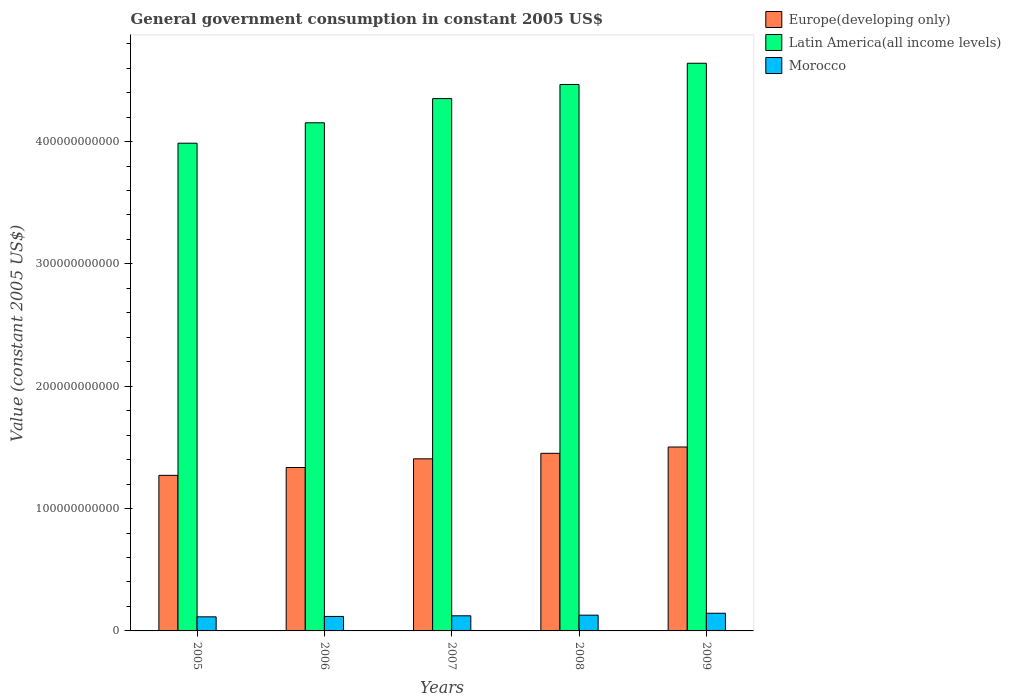Are the number of bars on each tick of the X-axis equal?
Offer a terse response. Yes. What is the label of the 2nd group of bars from the left?
Your answer should be very brief. 2006. In how many cases, is the number of bars for a given year not equal to the number of legend labels?
Keep it short and to the point. 0. What is the government conusmption in Morocco in 2007?
Your answer should be compact. 1.24e+1. Across all years, what is the maximum government conusmption in Europe(developing only)?
Offer a very short reply. 1.50e+11. Across all years, what is the minimum government conusmption in Morocco?
Your response must be concise. 1.15e+1. In which year was the government conusmption in Latin America(all income levels) maximum?
Give a very brief answer. 2009. What is the total government conusmption in Latin America(all income levels) in the graph?
Provide a succinct answer. 2.16e+12. What is the difference between the government conusmption in Latin America(all income levels) in 2006 and that in 2008?
Your answer should be very brief. -3.13e+1. What is the difference between the government conusmption in Latin America(all income levels) in 2005 and the government conusmption in Europe(developing only) in 2009?
Make the answer very short. 2.48e+11. What is the average government conusmption in Morocco per year?
Keep it short and to the point. 1.26e+1. In the year 2005, what is the difference between the government conusmption in Europe(developing only) and government conusmption in Morocco?
Offer a very short reply. 1.16e+11. In how many years, is the government conusmption in Morocco greater than 40000000000 US$?
Keep it short and to the point. 0. What is the ratio of the government conusmption in Morocco in 2006 to that in 2008?
Provide a short and direct response. 0.92. Is the difference between the government conusmption in Europe(developing only) in 2007 and 2009 greater than the difference between the government conusmption in Morocco in 2007 and 2009?
Provide a succinct answer. No. What is the difference between the highest and the second highest government conusmption in Europe(developing only)?
Keep it short and to the point. 5.17e+09. What is the difference between the highest and the lowest government conusmption in Morocco?
Offer a very short reply. 2.93e+09. Is the sum of the government conusmption in Europe(developing only) in 2007 and 2008 greater than the maximum government conusmption in Morocco across all years?
Provide a short and direct response. Yes. What does the 3rd bar from the left in 2009 represents?
Make the answer very short. Morocco. What does the 2nd bar from the right in 2006 represents?
Make the answer very short. Latin America(all income levels). Is it the case that in every year, the sum of the government conusmption in Morocco and government conusmption in Latin America(all income levels) is greater than the government conusmption in Europe(developing only)?
Make the answer very short. Yes. How many years are there in the graph?
Your answer should be compact. 5. What is the difference between two consecutive major ticks on the Y-axis?
Give a very brief answer. 1.00e+11. Are the values on the major ticks of Y-axis written in scientific E-notation?
Keep it short and to the point. No. Does the graph contain any zero values?
Keep it short and to the point. No. Does the graph contain grids?
Make the answer very short. No. Where does the legend appear in the graph?
Offer a very short reply. Top right. What is the title of the graph?
Your response must be concise. General government consumption in constant 2005 US$. Does "Uzbekistan" appear as one of the legend labels in the graph?
Ensure brevity in your answer.  No. What is the label or title of the Y-axis?
Provide a succinct answer. Value (constant 2005 US$). What is the Value (constant 2005 US$) of Europe(developing only) in 2005?
Provide a short and direct response. 1.27e+11. What is the Value (constant 2005 US$) in Latin America(all income levels) in 2005?
Your answer should be compact. 3.99e+11. What is the Value (constant 2005 US$) of Morocco in 2005?
Offer a terse response. 1.15e+1. What is the Value (constant 2005 US$) in Europe(developing only) in 2006?
Offer a very short reply. 1.34e+11. What is the Value (constant 2005 US$) in Latin America(all income levels) in 2006?
Offer a terse response. 4.15e+11. What is the Value (constant 2005 US$) of Morocco in 2006?
Make the answer very short. 1.18e+1. What is the Value (constant 2005 US$) in Europe(developing only) in 2007?
Provide a succinct answer. 1.41e+11. What is the Value (constant 2005 US$) in Latin America(all income levels) in 2007?
Offer a very short reply. 4.35e+11. What is the Value (constant 2005 US$) in Morocco in 2007?
Your answer should be very brief. 1.24e+1. What is the Value (constant 2005 US$) of Europe(developing only) in 2008?
Offer a very short reply. 1.45e+11. What is the Value (constant 2005 US$) of Latin America(all income levels) in 2008?
Your response must be concise. 4.47e+11. What is the Value (constant 2005 US$) of Morocco in 2008?
Your answer should be very brief. 1.29e+1. What is the Value (constant 2005 US$) of Europe(developing only) in 2009?
Give a very brief answer. 1.50e+11. What is the Value (constant 2005 US$) of Latin America(all income levels) in 2009?
Provide a succinct answer. 4.64e+11. What is the Value (constant 2005 US$) of Morocco in 2009?
Make the answer very short. 1.45e+1. Across all years, what is the maximum Value (constant 2005 US$) in Europe(developing only)?
Your answer should be compact. 1.50e+11. Across all years, what is the maximum Value (constant 2005 US$) of Latin America(all income levels)?
Ensure brevity in your answer.  4.64e+11. Across all years, what is the maximum Value (constant 2005 US$) in Morocco?
Make the answer very short. 1.45e+1. Across all years, what is the minimum Value (constant 2005 US$) in Europe(developing only)?
Ensure brevity in your answer.  1.27e+11. Across all years, what is the minimum Value (constant 2005 US$) in Latin America(all income levels)?
Provide a succinct answer. 3.99e+11. Across all years, what is the minimum Value (constant 2005 US$) of Morocco?
Provide a short and direct response. 1.15e+1. What is the total Value (constant 2005 US$) of Europe(developing only) in the graph?
Your answer should be very brief. 6.97e+11. What is the total Value (constant 2005 US$) of Latin America(all income levels) in the graph?
Your answer should be very brief. 2.16e+12. What is the total Value (constant 2005 US$) in Morocco in the graph?
Your answer should be very brief. 6.31e+1. What is the difference between the Value (constant 2005 US$) in Europe(developing only) in 2005 and that in 2006?
Keep it short and to the point. -6.40e+09. What is the difference between the Value (constant 2005 US$) in Latin America(all income levels) in 2005 and that in 2006?
Give a very brief answer. -1.67e+1. What is the difference between the Value (constant 2005 US$) of Morocco in 2005 and that in 2006?
Ensure brevity in your answer.  -3.30e+08. What is the difference between the Value (constant 2005 US$) in Europe(developing only) in 2005 and that in 2007?
Provide a short and direct response. -1.35e+1. What is the difference between the Value (constant 2005 US$) in Latin America(all income levels) in 2005 and that in 2007?
Give a very brief answer. -3.65e+1. What is the difference between the Value (constant 2005 US$) of Morocco in 2005 and that in 2007?
Offer a very short reply. -8.40e+08. What is the difference between the Value (constant 2005 US$) in Europe(developing only) in 2005 and that in 2008?
Your answer should be compact. -1.80e+1. What is the difference between the Value (constant 2005 US$) in Latin America(all income levels) in 2005 and that in 2008?
Ensure brevity in your answer.  -4.80e+1. What is the difference between the Value (constant 2005 US$) of Morocco in 2005 and that in 2008?
Offer a very short reply. -1.36e+09. What is the difference between the Value (constant 2005 US$) in Europe(developing only) in 2005 and that in 2009?
Provide a short and direct response. -2.32e+1. What is the difference between the Value (constant 2005 US$) of Latin America(all income levels) in 2005 and that in 2009?
Provide a short and direct response. -6.53e+1. What is the difference between the Value (constant 2005 US$) in Morocco in 2005 and that in 2009?
Make the answer very short. -2.93e+09. What is the difference between the Value (constant 2005 US$) of Europe(developing only) in 2006 and that in 2007?
Offer a terse response. -7.10e+09. What is the difference between the Value (constant 2005 US$) in Latin America(all income levels) in 2006 and that in 2007?
Make the answer very short. -1.98e+1. What is the difference between the Value (constant 2005 US$) of Morocco in 2006 and that in 2007?
Offer a terse response. -5.10e+08. What is the difference between the Value (constant 2005 US$) of Europe(developing only) in 2006 and that in 2008?
Make the answer very short. -1.16e+1. What is the difference between the Value (constant 2005 US$) in Latin America(all income levels) in 2006 and that in 2008?
Make the answer very short. -3.13e+1. What is the difference between the Value (constant 2005 US$) of Morocco in 2006 and that in 2008?
Make the answer very short. -1.03e+09. What is the difference between the Value (constant 2005 US$) of Europe(developing only) in 2006 and that in 2009?
Make the answer very short. -1.68e+1. What is the difference between the Value (constant 2005 US$) of Latin America(all income levels) in 2006 and that in 2009?
Your answer should be compact. -4.86e+1. What is the difference between the Value (constant 2005 US$) of Morocco in 2006 and that in 2009?
Offer a terse response. -2.60e+09. What is the difference between the Value (constant 2005 US$) of Europe(developing only) in 2007 and that in 2008?
Your response must be concise. -4.50e+09. What is the difference between the Value (constant 2005 US$) in Latin America(all income levels) in 2007 and that in 2008?
Your answer should be very brief. -1.15e+1. What is the difference between the Value (constant 2005 US$) of Morocco in 2007 and that in 2008?
Your response must be concise. -5.23e+08. What is the difference between the Value (constant 2005 US$) in Europe(developing only) in 2007 and that in 2009?
Your response must be concise. -9.67e+09. What is the difference between the Value (constant 2005 US$) in Latin America(all income levels) in 2007 and that in 2009?
Give a very brief answer. -2.89e+1. What is the difference between the Value (constant 2005 US$) in Morocco in 2007 and that in 2009?
Keep it short and to the point. -2.09e+09. What is the difference between the Value (constant 2005 US$) in Europe(developing only) in 2008 and that in 2009?
Provide a short and direct response. -5.17e+09. What is the difference between the Value (constant 2005 US$) in Latin America(all income levels) in 2008 and that in 2009?
Keep it short and to the point. -1.74e+1. What is the difference between the Value (constant 2005 US$) of Morocco in 2008 and that in 2009?
Your answer should be compact. -1.57e+09. What is the difference between the Value (constant 2005 US$) of Europe(developing only) in 2005 and the Value (constant 2005 US$) of Latin America(all income levels) in 2006?
Ensure brevity in your answer.  -2.88e+11. What is the difference between the Value (constant 2005 US$) in Europe(developing only) in 2005 and the Value (constant 2005 US$) in Morocco in 2006?
Provide a succinct answer. 1.15e+11. What is the difference between the Value (constant 2005 US$) of Latin America(all income levels) in 2005 and the Value (constant 2005 US$) of Morocco in 2006?
Your answer should be compact. 3.87e+11. What is the difference between the Value (constant 2005 US$) in Europe(developing only) in 2005 and the Value (constant 2005 US$) in Latin America(all income levels) in 2007?
Provide a succinct answer. -3.08e+11. What is the difference between the Value (constant 2005 US$) in Europe(developing only) in 2005 and the Value (constant 2005 US$) in Morocco in 2007?
Keep it short and to the point. 1.15e+11. What is the difference between the Value (constant 2005 US$) of Latin America(all income levels) in 2005 and the Value (constant 2005 US$) of Morocco in 2007?
Your answer should be compact. 3.86e+11. What is the difference between the Value (constant 2005 US$) of Europe(developing only) in 2005 and the Value (constant 2005 US$) of Latin America(all income levels) in 2008?
Keep it short and to the point. -3.19e+11. What is the difference between the Value (constant 2005 US$) of Europe(developing only) in 2005 and the Value (constant 2005 US$) of Morocco in 2008?
Your answer should be very brief. 1.14e+11. What is the difference between the Value (constant 2005 US$) in Latin America(all income levels) in 2005 and the Value (constant 2005 US$) in Morocco in 2008?
Your response must be concise. 3.86e+11. What is the difference between the Value (constant 2005 US$) in Europe(developing only) in 2005 and the Value (constant 2005 US$) in Latin America(all income levels) in 2009?
Provide a short and direct response. -3.37e+11. What is the difference between the Value (constant 2005 US$) in Europe(developing only) in 2005 and the Value (constant 2005 US$) in Morocco in 2009?
Offer a very short reply. 1.13e+11. What is the difference between the Value (constant 2005 US$) in Latin America(all income levels) in 2005 and the Value (constant 2005 US$) in Morocco in 2009?
Your response must be concise. 3.84e+11. What is the difference between the Value (constant 2005 US$) of Europe(developing only) in 2006 and the Value (constant 2005 US$) of Latin America(all income levels) in 2007?
Your response must be concise. -3.02e+11. What is the difference between the Value (constant 2005 US$) in Europe(developing only) in 2006 and the Value (constant 2005 US$) in Morocco in 2007?
Your response must be concise. 1.21e+11. What is the difference between the Value (constant 2005 US$) in Latin America(all income levels) in 2006 and the Value (constant 2005 US$) in Morocco in 2007?
Offer a very short reply. 4.03e+11. What is the difference between the Value (constant 2005 US$) in Europe(developing only) in 2006 and the Value (constant 2005 US$) in Latin America(all income levels) in 2008?
Give a very brief answer. -3.13e+11. What is the difference between the Value (constant 2005 US$) of Europe(developing only) in 2006 and the Value (constant 2005 US$) of Morocco in 2008?
Your answer should be compact. 1.21e+11. What is the difference between the Value (constant 2005 US$) in Latin America(all income levels) in 2006 and the Value (constant 2005 US$) in Morocco in 2008?
Your answer should be compact. 4.02e+11. What is the difference between the Value (constant 2005 US$) of Europe(developing only) in 2006 and the Value (constant 2005 US$) of Latin America(all income levels) in 2009?
Your answer should be very brief. -3.30e+11. What is the difference between the Value (constant 2005 US$) of Europe(developing only) in 2006 and the Value (constant 2005 US$) of Morocco in 2009?
Provide a succinct answer. 1.19e+11. What is the difference between the Value (constant 2005 US$) of Latin America(all income levels) in 2006 and the Value (constant 2005 US$) of Morocco in 2009?
Your answer should be very brief. 4.01e+11. What is the difference between the Value (constant 2005 US$) of Europe(developing only) in 2007 and the Value (constant 2005 US$) of Latin America(all income levels) in 2008?
Your answer should be compact. -3.06e+11. What is the difference between the Value (constant 2005 US$) in Europe(developing only) in 2007 and the Value (constant 2005 US$) in Morocco in 2008?
Make the answer very short. 1.28e+11. What is the difference between the Value (constant 2005 US$) in Latin America(all income levels) in 2007 and the Value (constant 2005 US$) in Morocco in 2008?
Offer a terse response. 4.22e+11. What is the difference between the Value (constant 2005 US$) of Europe(developing only) in 2007 and the Value (constant 2005 US$) of Latin America(all income levels) in 2009?
Provide a succinct answer. -3.23e+11. What is the difference between the Value (constant 2005 US$) in Europe(developing only) in 2007 and the Value (constant 2005 US$) in Morocco in 2009?
Make the answer very short. 1.26e+11. What is the difference between the Value (constant 2005 US$) of Latin America(all income levels) in 2007 and the Value (constant 2005 US$) of Morocco in 2009?
Keep it short and to the point. 4.21e+11. What is the difference between the Value (constant 2005 US$) in Europe(developing only) in 2008 and the Value (constant 2005 US$) in Latin America(all income levels) in 2009?
Ensure brevity in your answer.  -3.19e+11. What is the difference between the Value (constant 2005 US$) of Europe(developing only) in 2008 and the Value (constant 2005 US$) of Morocco in 2009?
Your answer should be compact. 1.31e+11. What is the difference between the Value (constant 2005 US$) of Latin America(all income levels) in 2008 and the Value (constant 2005 US$) of Morocco in 2009?
Make the answer very short. 4.32e+11. What is the average Value (constant 2005 US$) of Europe(developing only) per year?
Your response must be concise. 1.39e+11. What is the average Value (constant 2005 US$) in Latin America(all income levels) per year?
Provide a succinct answer. 4.32e+11. What is the average Value (constant 2005 US$) in Morocco per year?
Make the answer very short. 1.26e+1. In the year 2005, what is the difference between the Value (constant 2005 US$) of Europe(developing only) and Value (constant 2005 US$) of Latin America(all income levels)?
Your response must be concise. -2.71e+11. In the year 2005, what is the difference between the Value (constant 2005 US$) in Europe(developing only) and Value (constant 2005 US$) in Morocco?
Your answer should be compact. 1.16e+11. In the year 2005, what is the difference between the Value (constant 2005 US$) in Latin America(all income levels) and Value (constant 2005 US$) in Morocco?
Your answer should be compact. 3.87e+11. In the year 2006, what is the difference between the Value (constant 2005 US$) of Europe(developing only) and Value (constant 2005 US$) of Latin America(all income levels)?
Your response must be concise. -2.82e+11. In the year 2006, what is the difference between the Value (constant 2005 US$) in Europe(developing only) and Value (constant 2005 US$) in Morocco?
Ensure brevity in your answer.  1.22e+11. In the year 2006, what is the difference between the Value (constant 2005 US$) of Latin America(all income levels) and Value (constant 2005 US$) of Morocco?
Keep it short and to the point. 4.03e+11. In the year 2007, what is the difference between the Value (constant 2005 US$) of Europe(developing only) and Value (constant 2005 US$) of Latin America(all income levels)?
Give a very brief answer. -2.94e+11. In the year 2007, what is the difference between the Value (constant 2005 US$) in Europe(developing only) and Value (constant 2005 US$) in Morocco?
Your response must be concise. 1.28e+11. In the year 2007, what is the difference between the Value (constant 2005 US$) in Latin America(all income levels) and Value (constant 2005 US$) in Morocco?
Your response must be concise. 4.23e+11. In the year 2008, what is the difference between the Value (constant 2005 US$) of Europe(developing only) and Value (constant 2005 US$) of Latin America(all income levels)?
Keep it short and to the point. -3.01e+11. In the year 2008, what is the difference between the Value (constant 2005 US$) in Europe(developing only) and Value (constant 2005 US$) in Morocco?
Offer a terse response. 1.32e+11. In the year 2008, what is the difference between the Value (constant 2005 US$) in Latin America(all income levels) and Value (constant 2005 US$) in Morocco?
Provide a short and direct response. 4.34e+11. In the year 2009, what is the difference between the Value (constant 2005 US$) of Europe(developing only) and Value (constant 2005 US$) of Latin America(all income levels)?
Your answer should be very brief. -3.14e+11. In the year 2009, what is the difference between the Value (constant 2005 US$) in Europe(developing only) and Value (constant 2005 US$) in Morocco?
Your answer should be very brief. 1.36e+11. In the year 2009, what is the difference between the Value (constant 2005 US$) of Latin America(all income levels) and Value (constant 2005 US$) of Morocco?
Your answer should be compact. 4.50e+11. What is the ratio of the Value (constant 2005 US$) in Europe(developing only) in 2005 to that in 2006?
Provide a succinct answer. 0.95. What is the ratio of the Value (constant 2005 US$) in Latin America(all income levels) in 2005 to that in 2006?
Offer a terse response. 0.96. What is the ratio of the Value (constant 2005 US$) of Morocco in 2005 to that in 2006?
Make the answer very short. 0.97. What is the ratio of the Value (constant 2005 US$) in Europe(developing only) in 2005 to that in 2007?
Ensure brevity in your answer.  0.9. What is the ratio of the Value (constant 2005 US$) in Latin America(all income levels) in 2005 to that in 2007?
Your answer should be compact. 0.92. What is the ratio of the Value (constant 2005 US$) in Morocco in 2005 to that in 2007?
Offer a very short reply. 0.93. What is the ratio of the Value (constant 2005 US$) of Europe(developing only) in 2005 to that in 2008?
Your answer should be very brief. 0.88. What is the ratio of the Value (constant 2005 US$) of Latin America(all income levels) in 2005 to that in 2008?
Your answer should be compact. 0.89. What is the ratio of the Value (constant 2005 US$) in Morocco in 2005 to that in 2008?
Your answer should be very brief. 0.89. What is the ratio of the Value (constant 2005 US$) of Europe(developing only) in 2005 to that in 2009?
Provide a short and direct response. 0.85. What is the ratio of the Value (constant 2005 US$) of Latin America(all income levels) in 2005 to that in 2009?
Keep it short and to the point. 0.86. What is the ratio of the Value (constant 2005 US$) in Morocco in 2005 to that in 2009?
Make the answer very short. 0.8. What is the ratio of the Value (constant 2005 US$) in Europe(developing only) in 2006 to that in 2007?
Your response must be concise. 0.95. What is the ratio of the Value (constant 2005 US$) of Latin America(all income levels) in 2006 to that in 2007?
Provide a short and direct response. 0.95. What is the ratio of the Value (constant 2005 US$) in Morocco in 2006 to that in 2007?
Your answer should be very brief. 0.96. What is the ratio of the Value (constant 2005 US$) in Europe(developing only) in 2006 to that in 2008?
Your response must be concise. 0.92. What is the ratio of the Value (constant 2005 US$) in Latin America(all income levels) in 2006 to that in 2008?
Your answer should be very brief. 0.93. What is the ratio of the Value (constant 2005 US$) in Morocco in 2006 to that in 2008?
Offer a very short reply. 0.92. What is the ratio of the Value (constant 2005 US$) of Europe(developing only) in 2006 to that in 2009?
Give a very brief answer. 0.89. What is the ratio of the Value (constant 2005 US$) of Latin America(all income levels) in 2006 to that in 2009?
Your response must be concise. 0.9. What is the ratio of the Value (constant 2005 US$) of Morocco in 2006 to that in 2009?
Provide a succinct answer. 0.82. What is the ratio of the Value (constant 2005 US$) in Latin America(all income levels) in 2007 to that in 2008?
Provide a succinct answer. 0.97. What is the ratio of the Value (constant 2005 US$) of Morocco in 2007 to that in 2008?
Offer a very short reply. 0.96. What is the ratio of the Value (constant 2005 US$) in Europe(developing only) in 2007 to that in 2009?
Keep it short and to the point. 0.94. What is the ratio of the Value (constant 2005 US$) of Latin America(all income levels) in 2007 to that in 2009?
Provide a succinct answer. 0.94. What is the ratio of the Value (constant 2005 US$) in Morocco in 2007 to that in 2009?
Offer a very short reply. 0.86. What is the ratio of the Value (constant 2005 US$) of Europe(developing only) in 2008 to that in 2009?
Provide a short and direct response. 0.97. What is the ratio of the Value (constant 2005 US$) in Latin America(all income levels) in 2008 to that in 2009?
Your answer should be very brief. 0.96. What is the ratio of the Value (constant 2005 US$) in Morocco in 2008 to that in 2009?
Provide a short and direct response. 0.89. What is the difference between the highest and the second highest Value (constant 2005 US$) in Europe(developing only)?
Provide a succinct answer. 5.17e+09. What is the difference between the highest and the second highest Value (constant 2005 US$) of Latin America(all income levels)?
Your answer should be very brief. 1.74e+1. What is the difference between the highest and the second highest Value (constant 2005 US$) of Morocco?
Make the answer very short. 1.57e+09. What is the difference between the highest and the lowest Value (constant 2005 US$) of Europe(developing only)?
Your answer should be compact. 2.32e+1. What is the difference between the highest and the lowest Value (constant 2005 US$) of Latin America(all income levels)?
Offer a terse response. 6.53e+1. What is the difference between the highest and the lowest Value (constant 2005 US$) of Morocco?
Keep it short and to the point. 2.93e+09. 